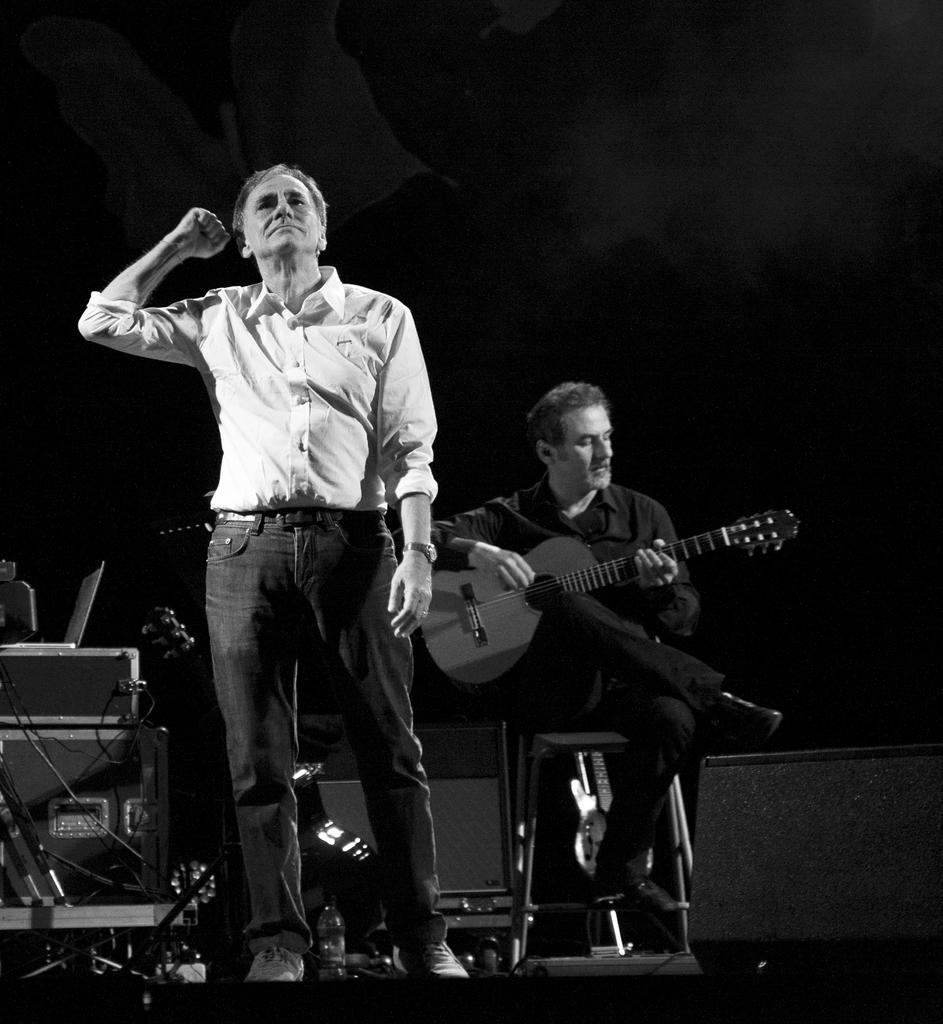What is the person standing in the image doing? The standing person is not doing any specific action in the image. What color is the shirt worn by the standing person? The standing person is wearing a white shirt. What is the sitting person in the image doing? The sitting person is playing a guitar. What color is the dress worn by the sitting person? The sitting person is wearing a black dress. What is the color of the background in the image? The background in the image is black. Can you tell me how many books are visible in the image? There are no books present in the image. What direction is the celery growing in the image? There is no celery present in the image. 